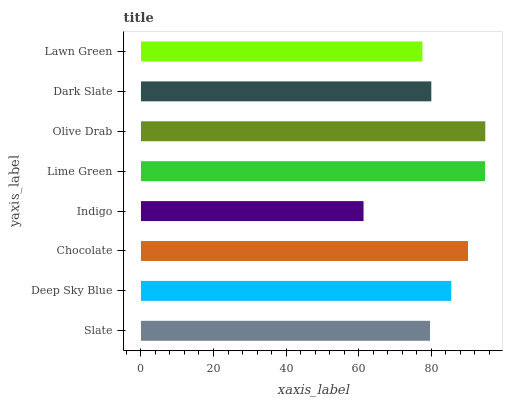Is Indigo the minimum?
Answer yes or no. Yes. Is Olive Drab the maximum?
Answer yes or no. Yes. Is Deep Sky Blue the minimum?
Answer yes or no. No. Is Deep Sky Blue the maximum?
Answer yes or no. No. Is Deep Sky Blue greater than Slate?
Answer yes or no. Yes. Is Slate less than Deep Sky Blue?
Answer yes or no. Yes. Is Slate greater than Deep Sky Blue?
Answer yes or no. No. Is Deep Sky Blue less than Slate?
Answer yes or no. No. Is Deep Sky Blue the high median?
Answer yes or no. Yes. Is Dark Slate the low median?
Answer yes or no. Yes. Is Indigo the high median?
Answer yes or no. No. Is Chocolate the low median?
Answer yes or no. No. 